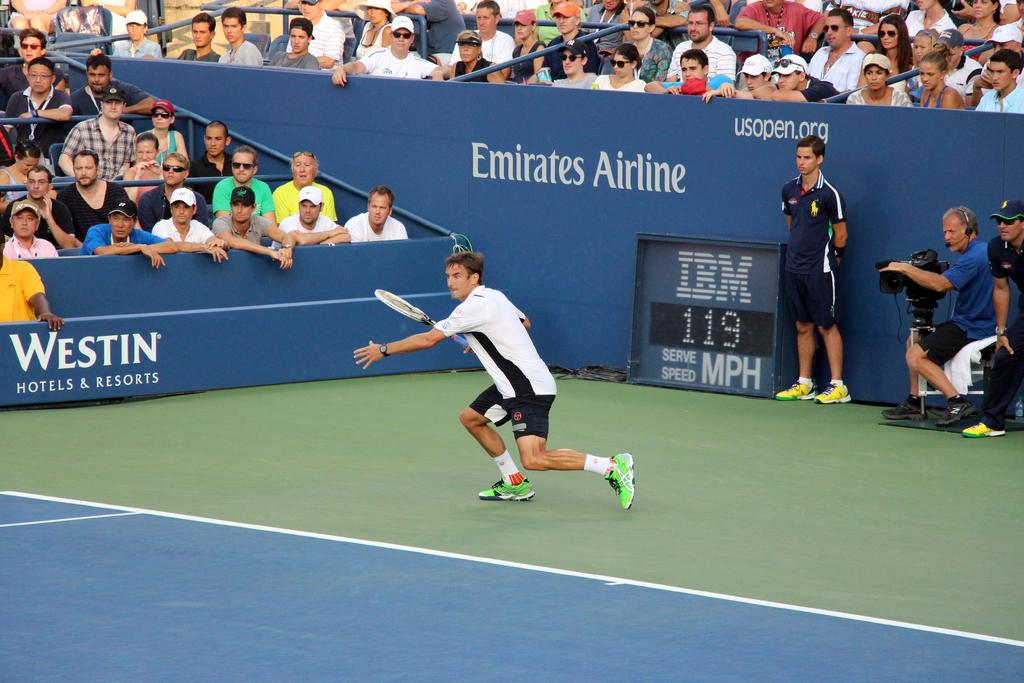What is the person in the foreground of the image holding? The person in the foreground of the image is holding a racket. What are the people in the background of the image doing? The people in the background of the image are sitting on chairs. Can you describe the person on the right side of the image? The person on the right side of the image is sitting and holding a camera. How many bases are visible in the image? There are no bases present in the image. What type of shoes is the person wearing on their feet in the image? The provided facts do not mention the person's footwear, so it cannot be determined from the image. 